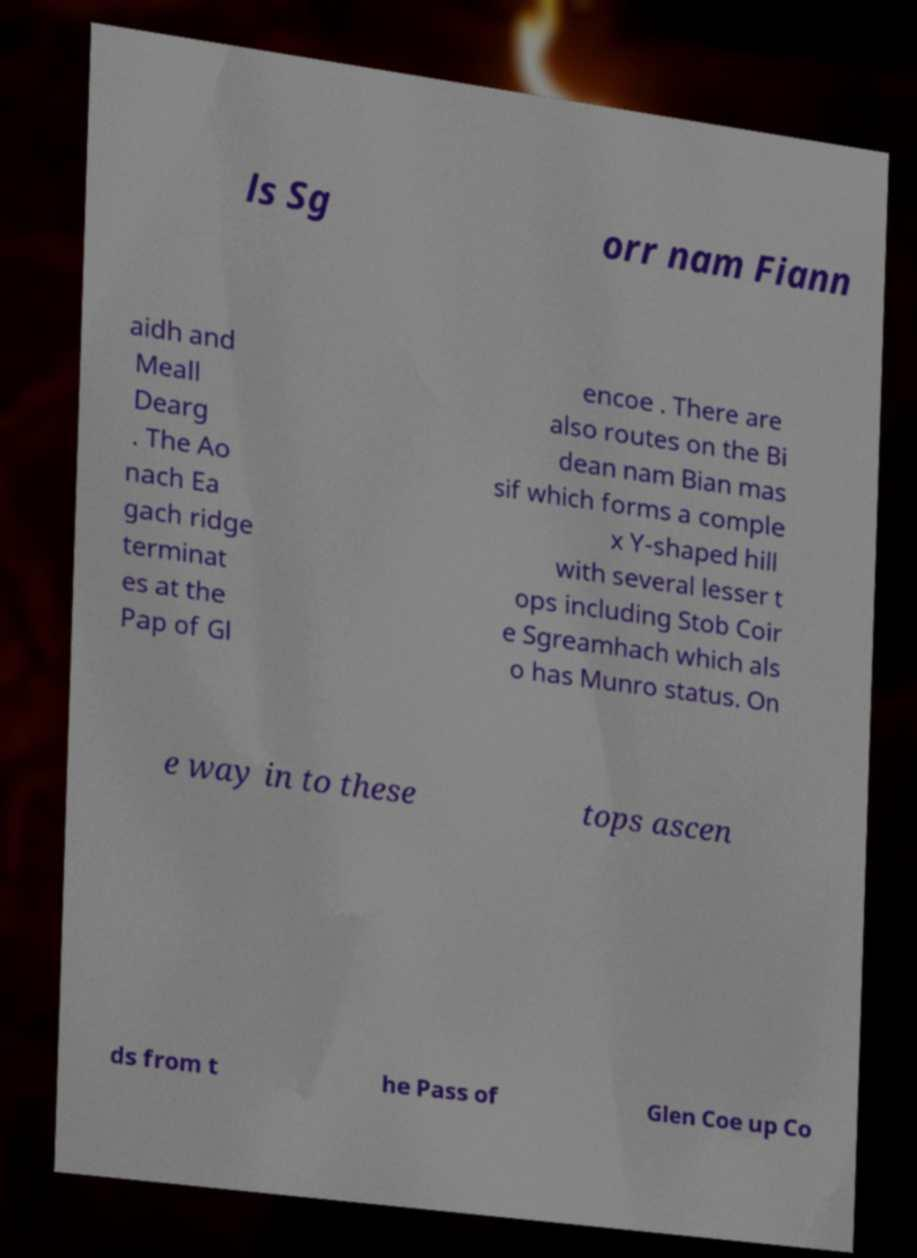What messages or text are displayed in this image? I need them in a readable, typed format. ls Sg orr nam Fiann aidh and Meall Dearg . The Ao nach Ea gach ridge terminat es at the Pap of Gl encoe . There are also routes on the Bi dean nam Bian mas sif which forms a comple x Y-shaped hill with several lesser t ops including Stob Coir e Sgreamhach which als o has Munro status. On e way in to these tops ascen ds from t he Pass of Glen Coe up Co 